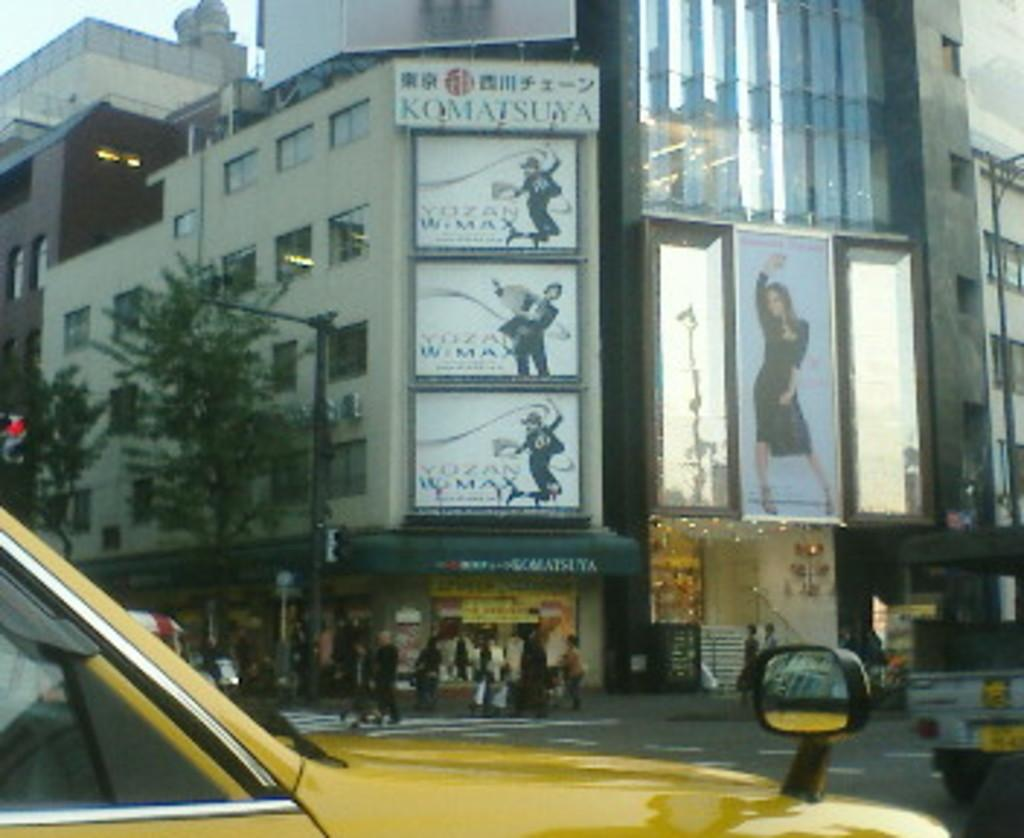What is happening on the road in the image? There are vehicles on the road in the image. What can be seen in the background of the image? In the background, there are people, buildings, hoardings, trees, and the sky. Can you describe the buildings in the background? The buildings in the background are not described in detail, but they are visible. What type of signage is present in the background? Hoardings are present in the background. What type of dirt can be seen on the vehicles in the image? There is no dirt visible on the vehicles in the image; they appear clean. What type of drug is being advertised on the hoardings in the image? There is no drug being advertised on the hoardings in the image; the content of the hoardings is not described. 